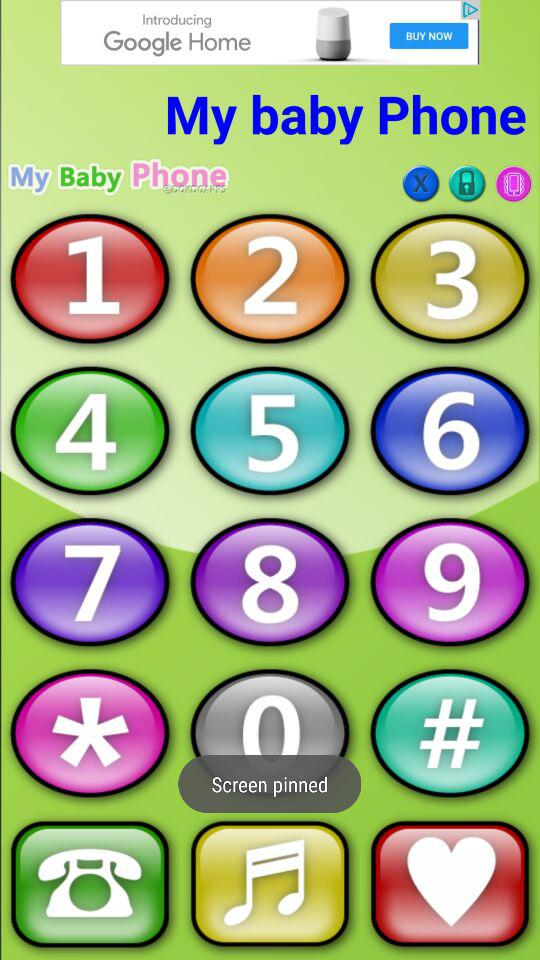What is the name of the application? The name of the application is "My baby Phone". 